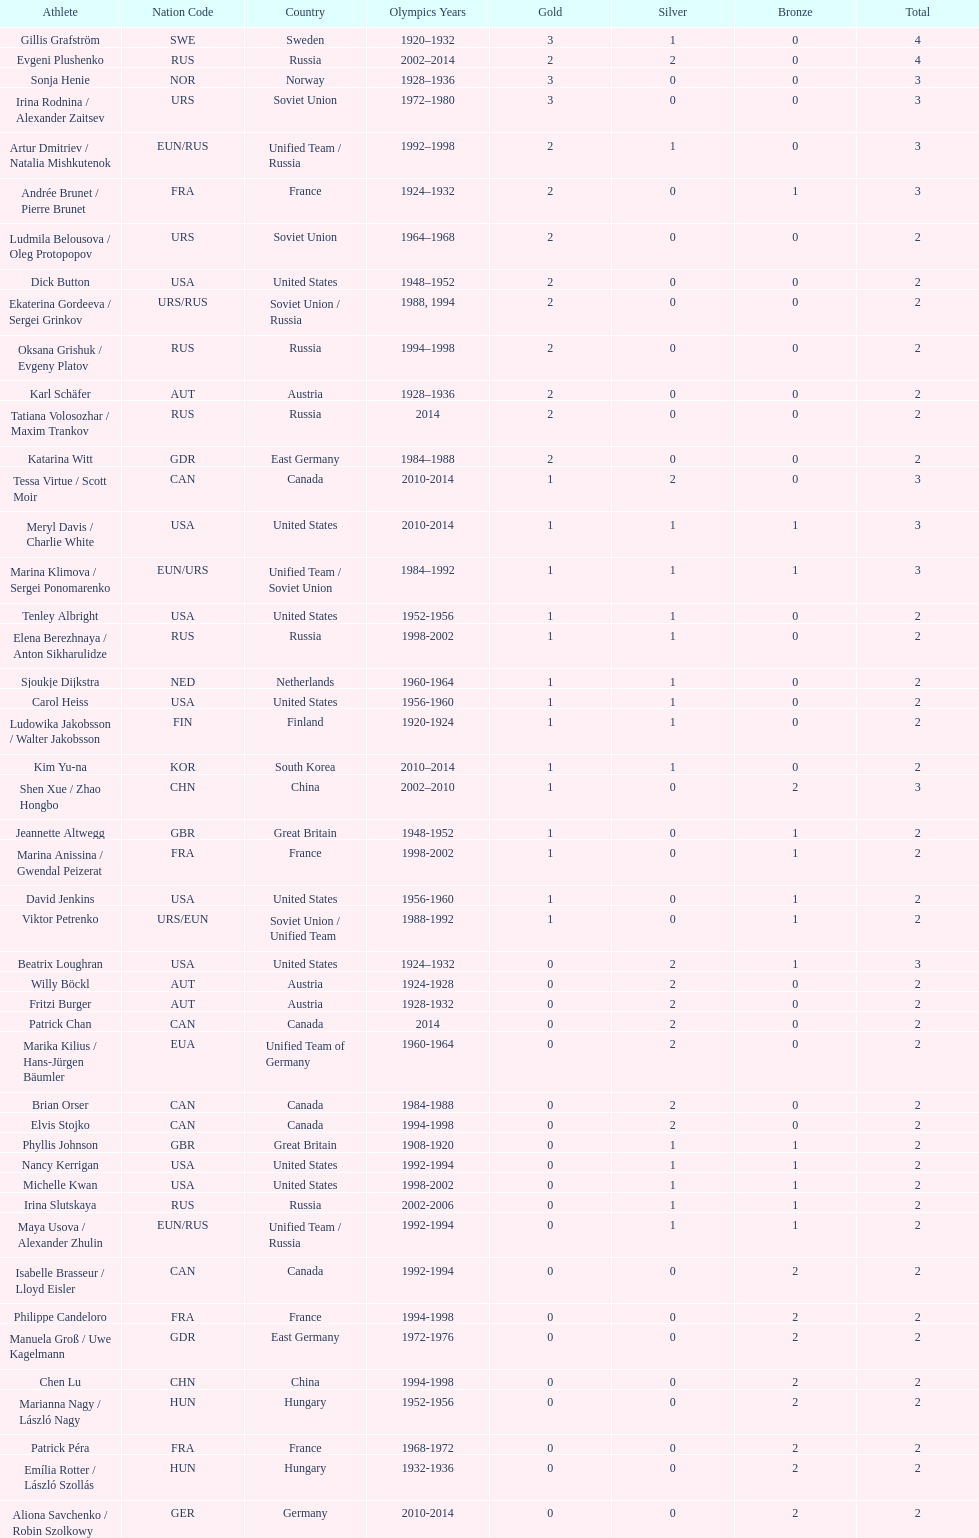Which nation was the first to win three gold medals for olympic figure skating? Sweden. 